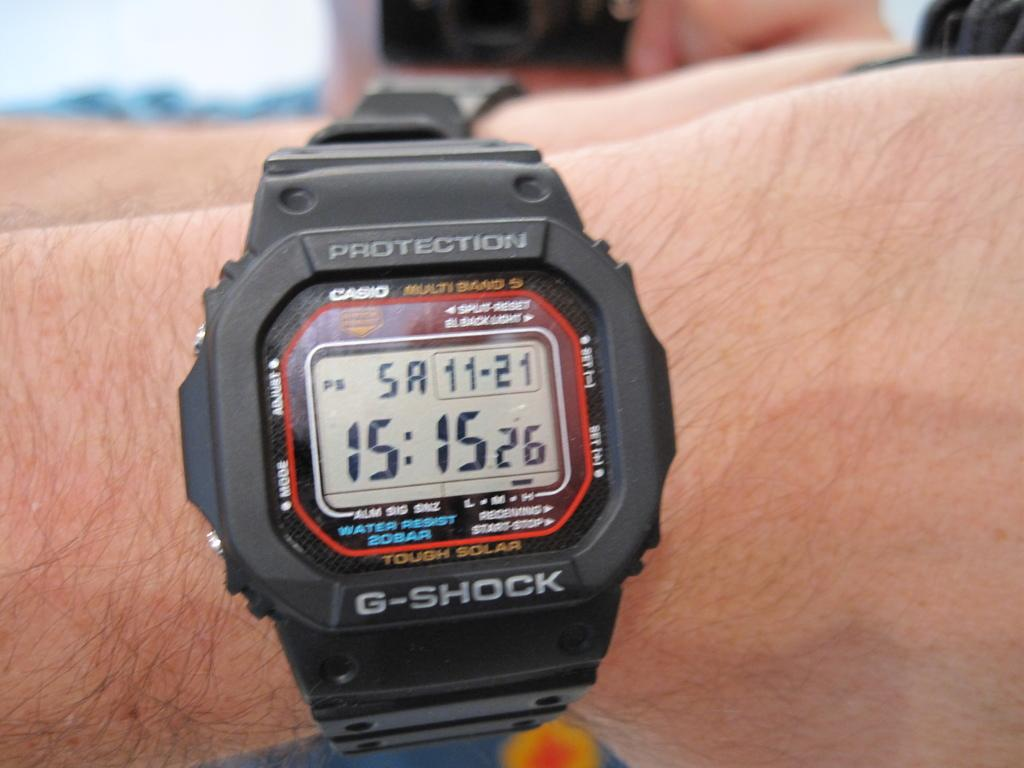Provide a one-sentence caption for the provided image. A hand wearing a black protection g shock branded watch whose time reads 15:15. 